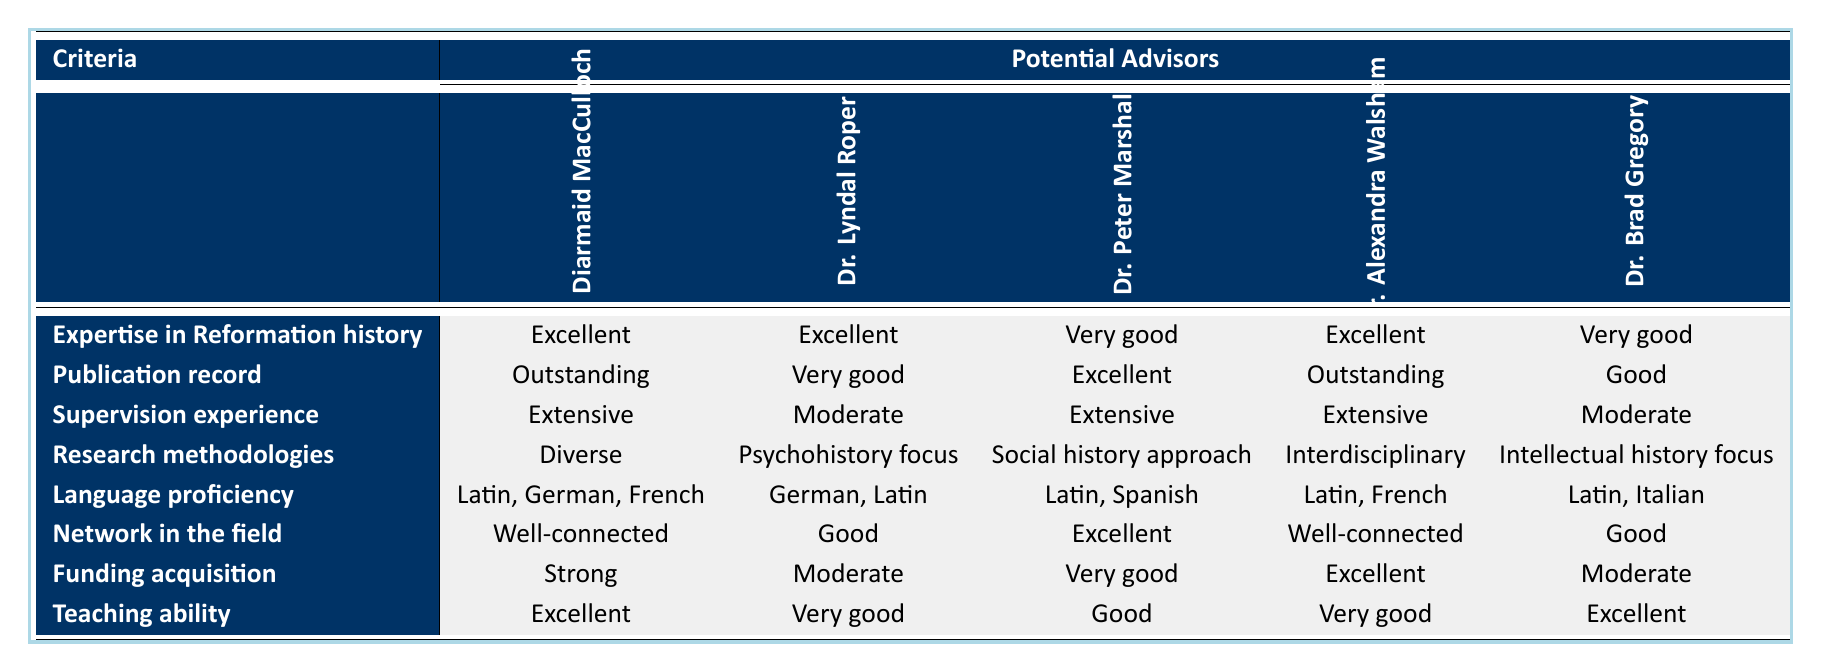What is the expertise level of Dr. Diarmaid MacCulloch in Reformation history? Dr. Diarmaid MacCulloch is rated as "Excellent" in expertise in Reformation history according to the table.
Answer: Excellent Which advisor has the strongest publication record? Dr. Diarmaid MacCulloch and Dr. Alexandra Walsham both have an "Outstanding" publication record, which is the highest rating in this category.
Answer: Dr. Diarmaid MacCulloch and Dr. Alexandra Walsham What is the language proficiency of Dr. Peter Marshall? According to the table, Dr. Peter Marshall is proficient in Latin and Spanish.
Answer: Latin, Spanish How many advisors have extensive supervision experience? Three advisors—Dr. Diarmaid MacCulloch, Dr. Peter Marshall, and Dr. Alexandra Walsham—are listed with "Extensive" supervision experience.
Answer: 3 Is Dr. Brad Gregory well-connected in the field? No, Dr. Brad Gregory is rated as "Good" in his network in the field, which is not the top tier of "Well-connected."
Answer: No Which advisor has a "Moderate" rating in funding acquisition? Both Dr. Lyndal Roper and Dr. Brad Gregory have a "Moderate" rating in funding acquisition according to the table.
Answer: Dr. Lyndal Roper and Dr. Brad Gregory If we average the teaching ability ratings of all five advisors, what is the result? Assigning numerical values (Excellent=4, Very Good=3, Good=2, Moderate=1) gives: (4 + 3 + 2 + 3 + 4) = 16. Dividing by 5 advisors results in an average of 16/5 = 3.2, which corresponds to between "Very Good" and "Excellent".
Answer: 3.2 Which research methodology is unique to Dr. Lyndal Roper? Dr. Lyndal Roper uses a "Psychohistory focus," which is the only methodology listed in the table specific to her compared to the other advisors.
Answer: Psychohistory focus How does the funding acquisition of Dr. Alexandra Walsham compare to Dr. Peter Marshall? Dr. Alexandra Walsham has an "Excellent" rating in funding acquisition, while Dr. Peter Marshall has a "Very good" rating. This indicates that Dr. Walsham has a higher level of funding success compared to Dr. Marshall.
Answer: Better 